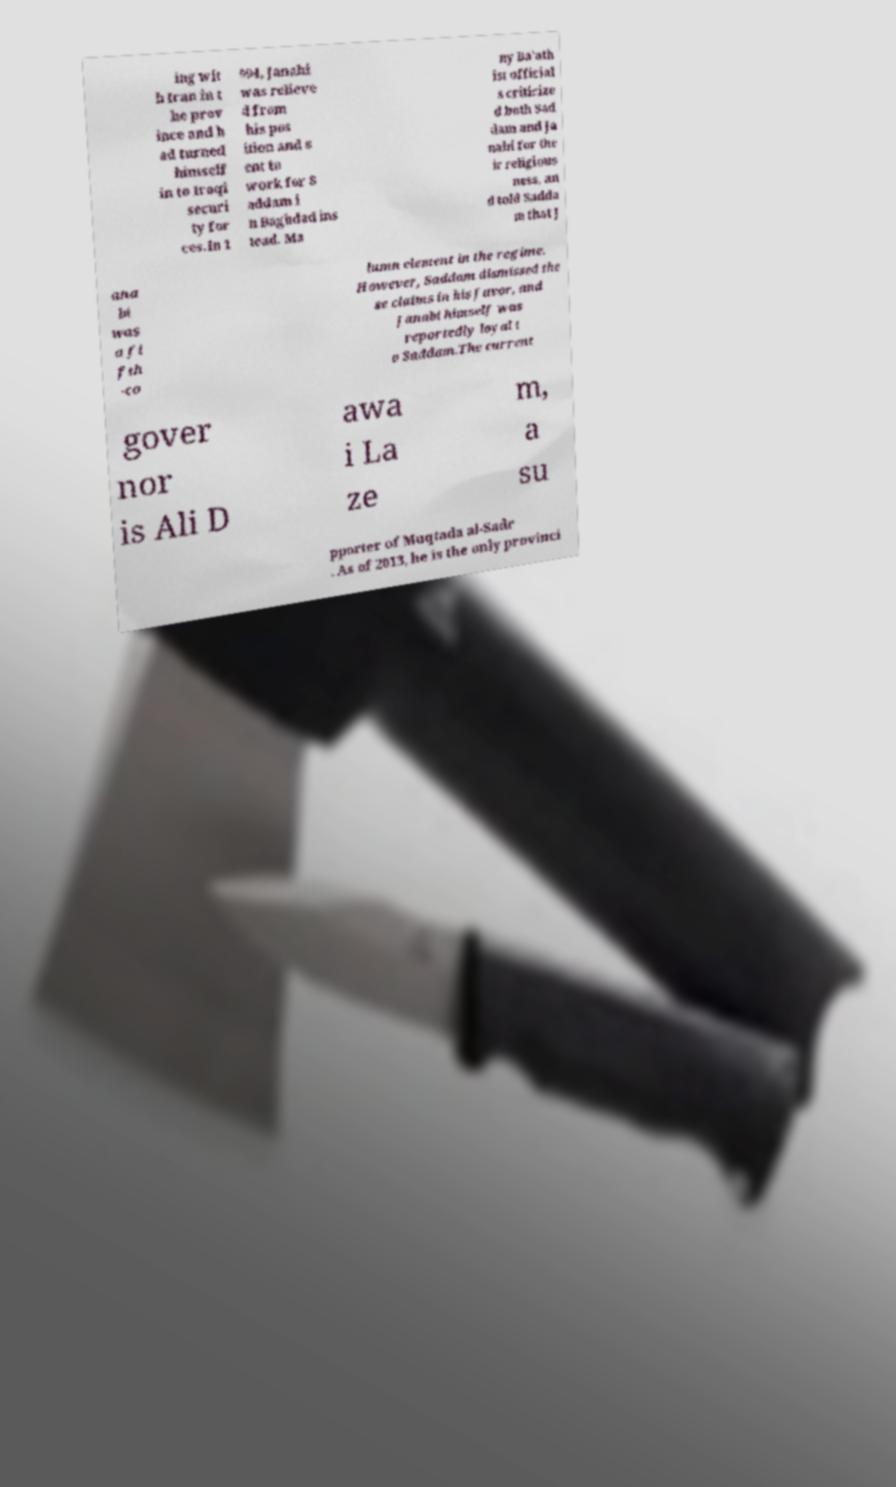Can you accurately transcribe the text from the provided image for me? ing wit h Iran in t he prov ince and h ad turned himself in to Iraqi securi ty for ces.In 1 994, Janabi was relieve d from his pos ition and s ent to work for S addam i n Baghdad ins tead. Ma ny Ba'ath ist official s criticize d both Sad dam and Ja nabi for the ir religious ness, an d told Sadda m that J ana bi was a fi fth -co lumn element in the regime. However, Saddam dismissed the se claims in his favor, and Janabi himself was reportedly loyal t o Saddam.The current gover nor is Ali D awa i La ze m, a su pporter of Muqtada al-Sadr . As of 2013, he is the only provinci 